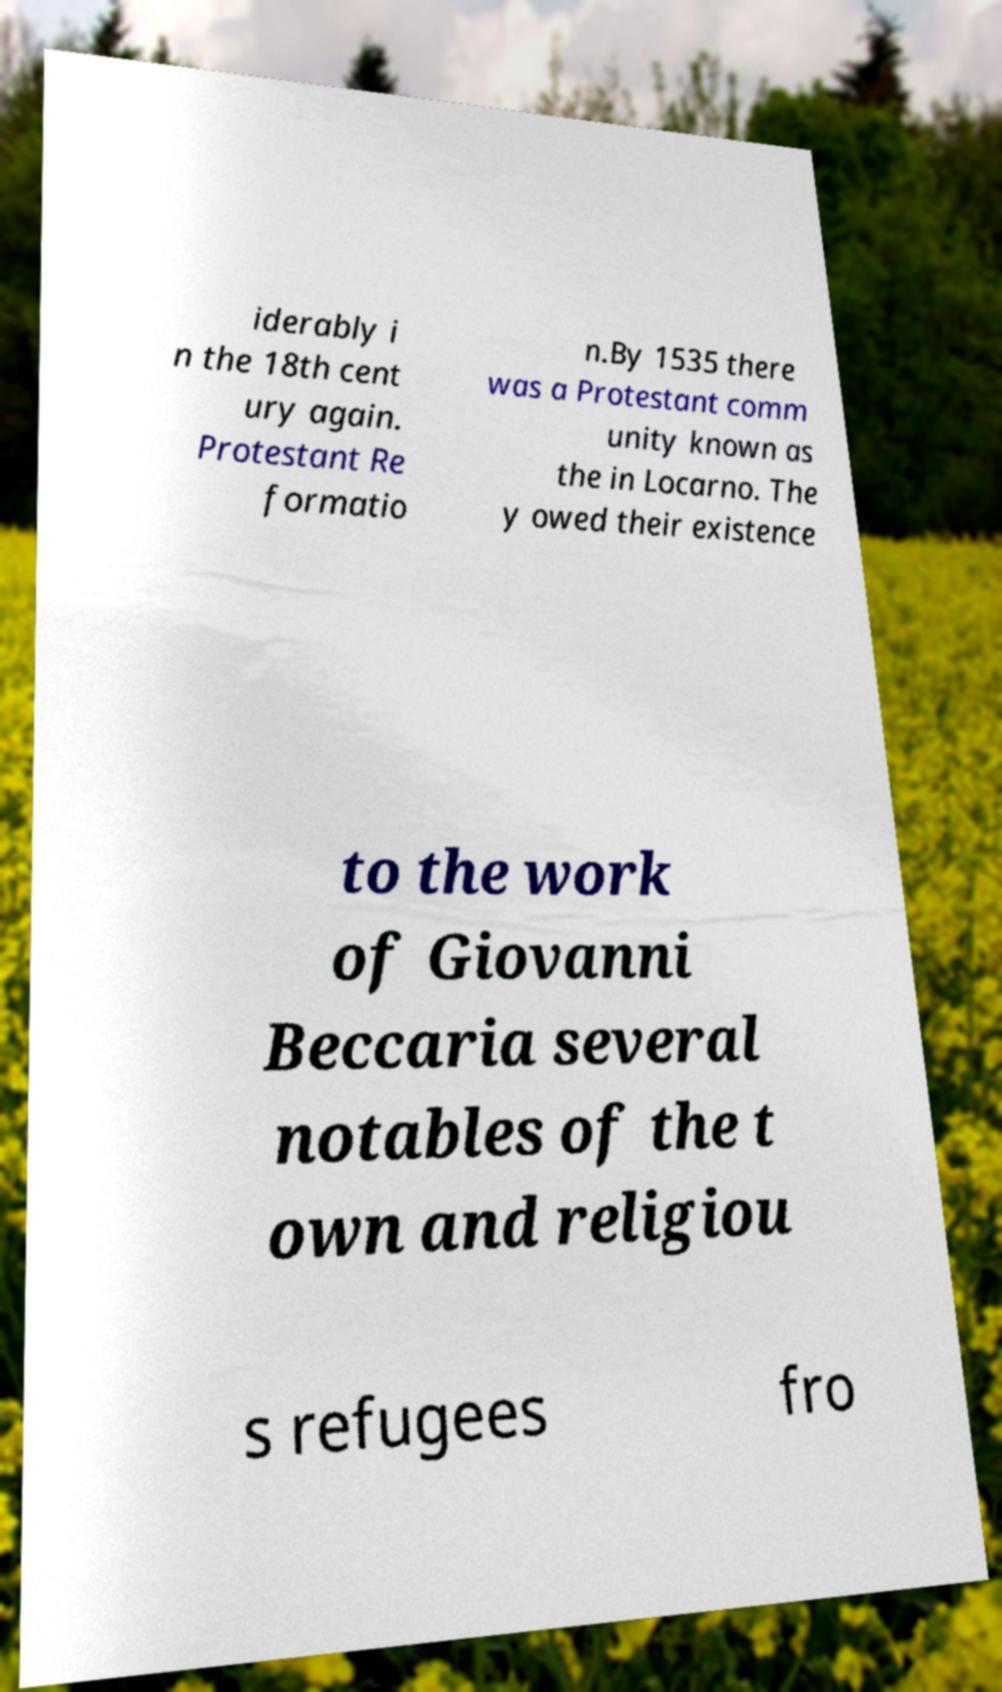For documentation purposes, I need the text within this image transcribed. Could you provide that? iderably i n the 18th cent ury again. Protestant Re formatio n.By 1535 there was a Protestant comm unity known as the in Locarno. The y owed their existence to the work of Giovanni Beccaria several notables of the t own and religiou s refugees fro 